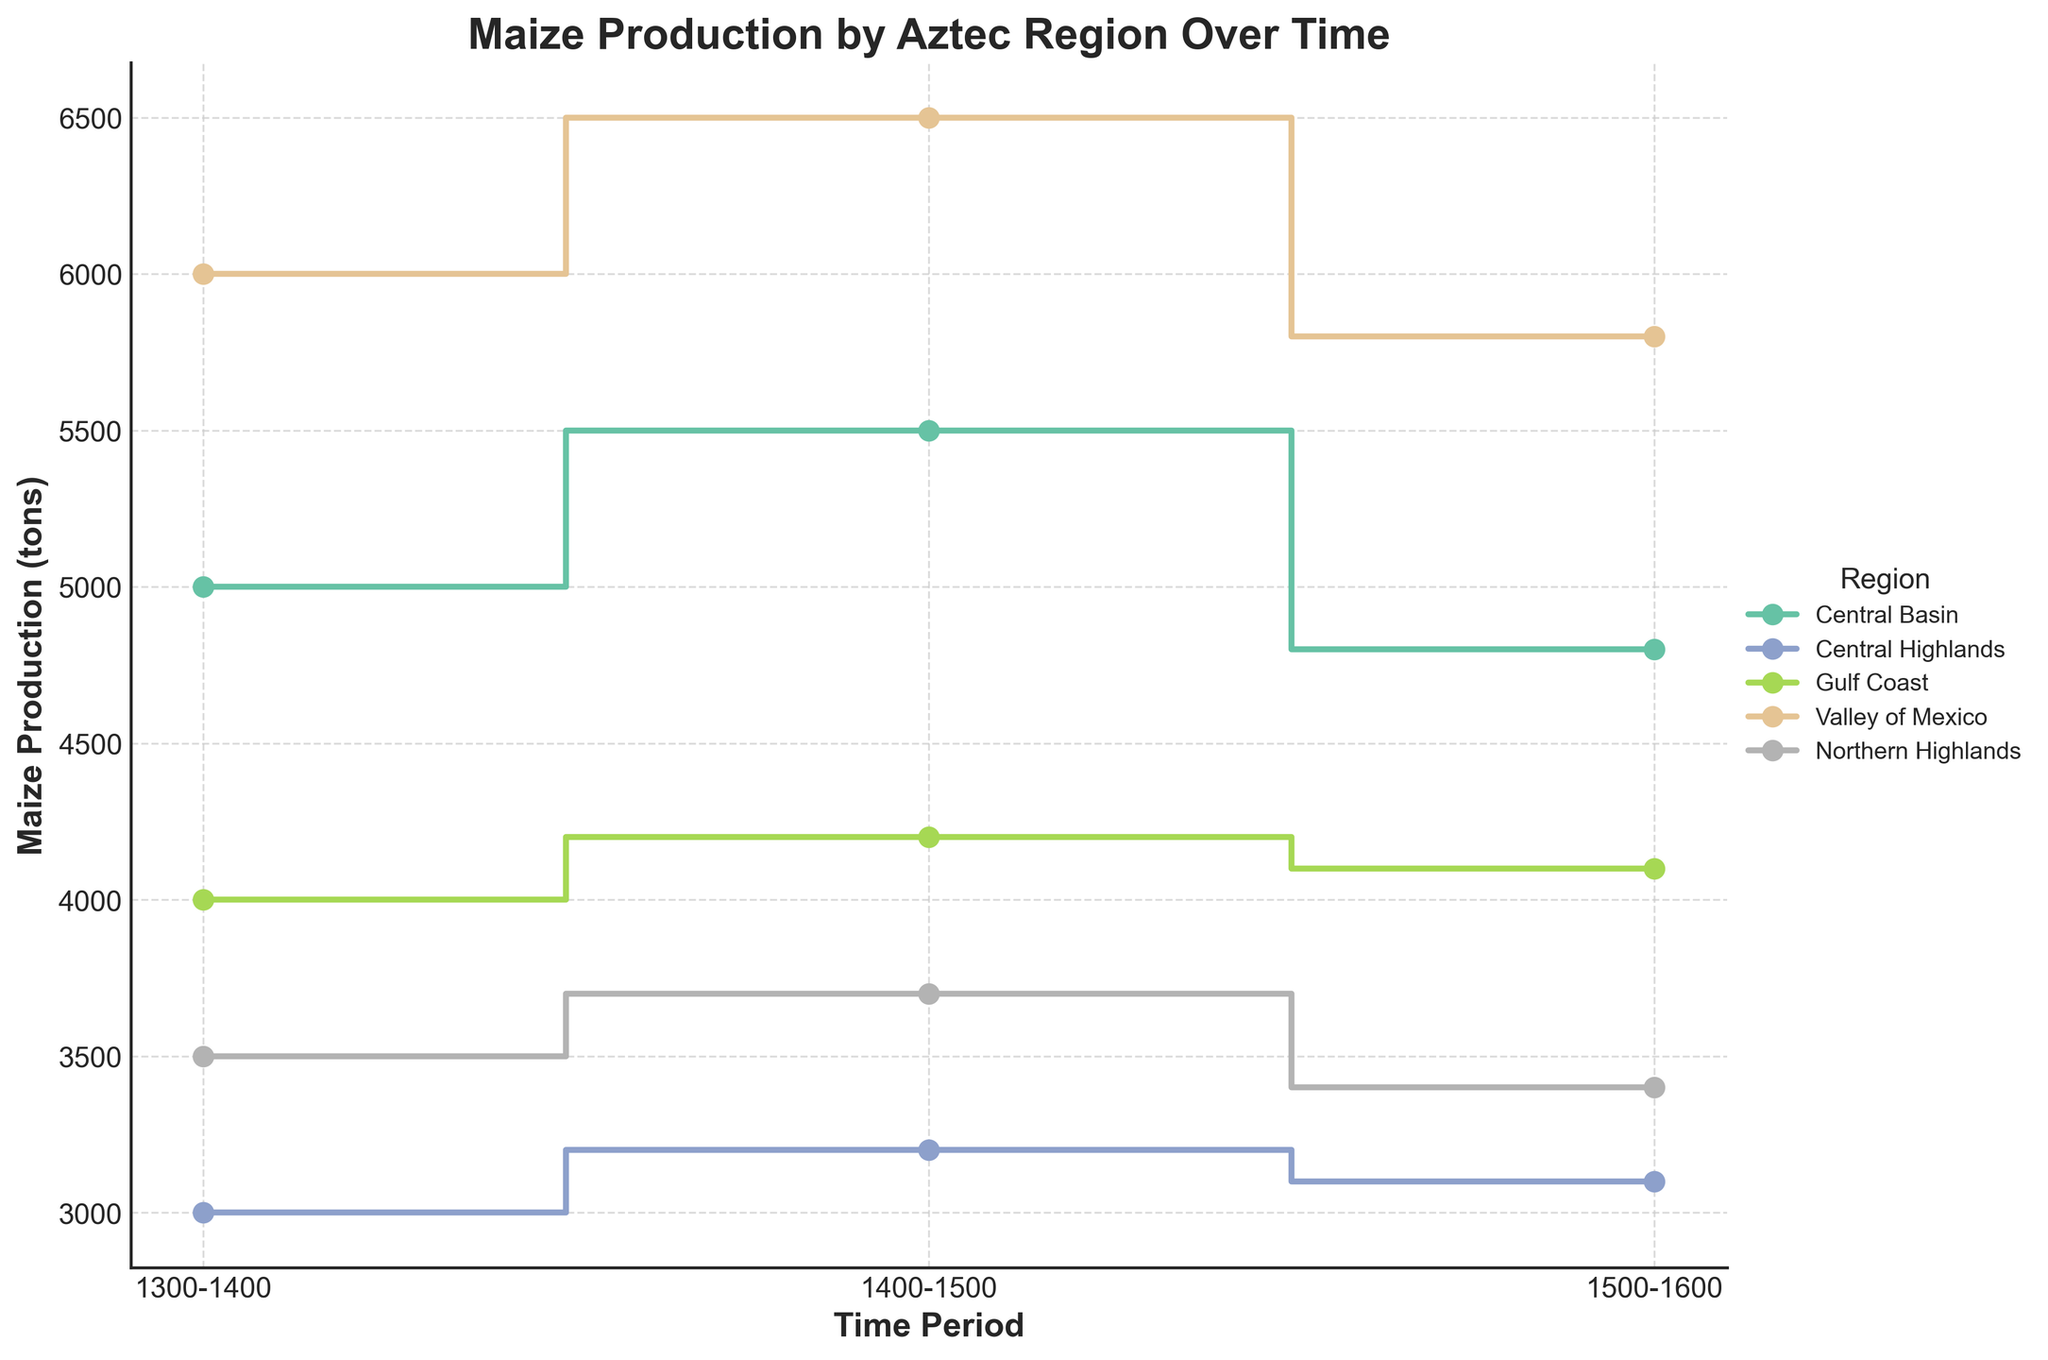What is the title of the plot? The title is prominently displayed at the top of the plot.
Answer: Maize Production by Aztec Region Over Time What are the regions represented in the plot? The regions are shown in the legend on the right side of the plot. They each have a unique color associated with them.
Answer: Central Basin, Central Highlands, Gulf Coast, Valley of Mexico, Northern Highlands Which region produced the most maize in the 1300-1400 time period? By examining the y-axis values for the different regions in the 1300-1400 period, the region with the highest maize production can be identified.
Answer: Valley of Mexico How does maize production in the Central Basin change from the 1300-1400 to 1400-1500 time periods? The step plot's markers for the Central Basin in the 1300-1400 and 1400-1500 periods can be compared to determine the change.
Answer: It increases from 5000 tons to 5500 tons Which two regions had a decrease in maize production from the 1400-1500 to 1500-1600 time periods? By comparing the y-axis values for all the regions in the 1400-1500 and 1500-1600 periods, the regions with a decrease in production can be identified.
Answer: Central Basin, Valley of Mexico Which region has the most stable maize production over the three time periods? By examining the step plot for the regions and looking for minimal changes in maize production across the three time periods, the region with the most stable production can be identified.
Answer: Central Highlands What is the difference in maize production between the Valley of Mexico and Northern Highlands in the 1500-1600 time period? The maize production values for Valley of Mexico and Northern Highlands in the 1500-1600 period can be subtracted to find the difference.
Answer: 5800 - 3400 = 2400 tons Which region had the highest increase in maize production from the 1300-1400 to 1500-1600 time periods? By calculating the difference in maize production between the 1300-1400 and 1500-1600 periods for all regions, the region with the highest increase can be identified.
Answer: Valley of Mexico How does the maize production pattern in the Central Basin compare to the pattern in the Gulf Coast over time? This involves comparing the trends (increases and decreases) in maize production for the Central Basin and Gulf Coast across the three time periods.
Answer: Central Basin shows an increase, then decrease; Gulf Coast shows a slight increase, then slight decrease 